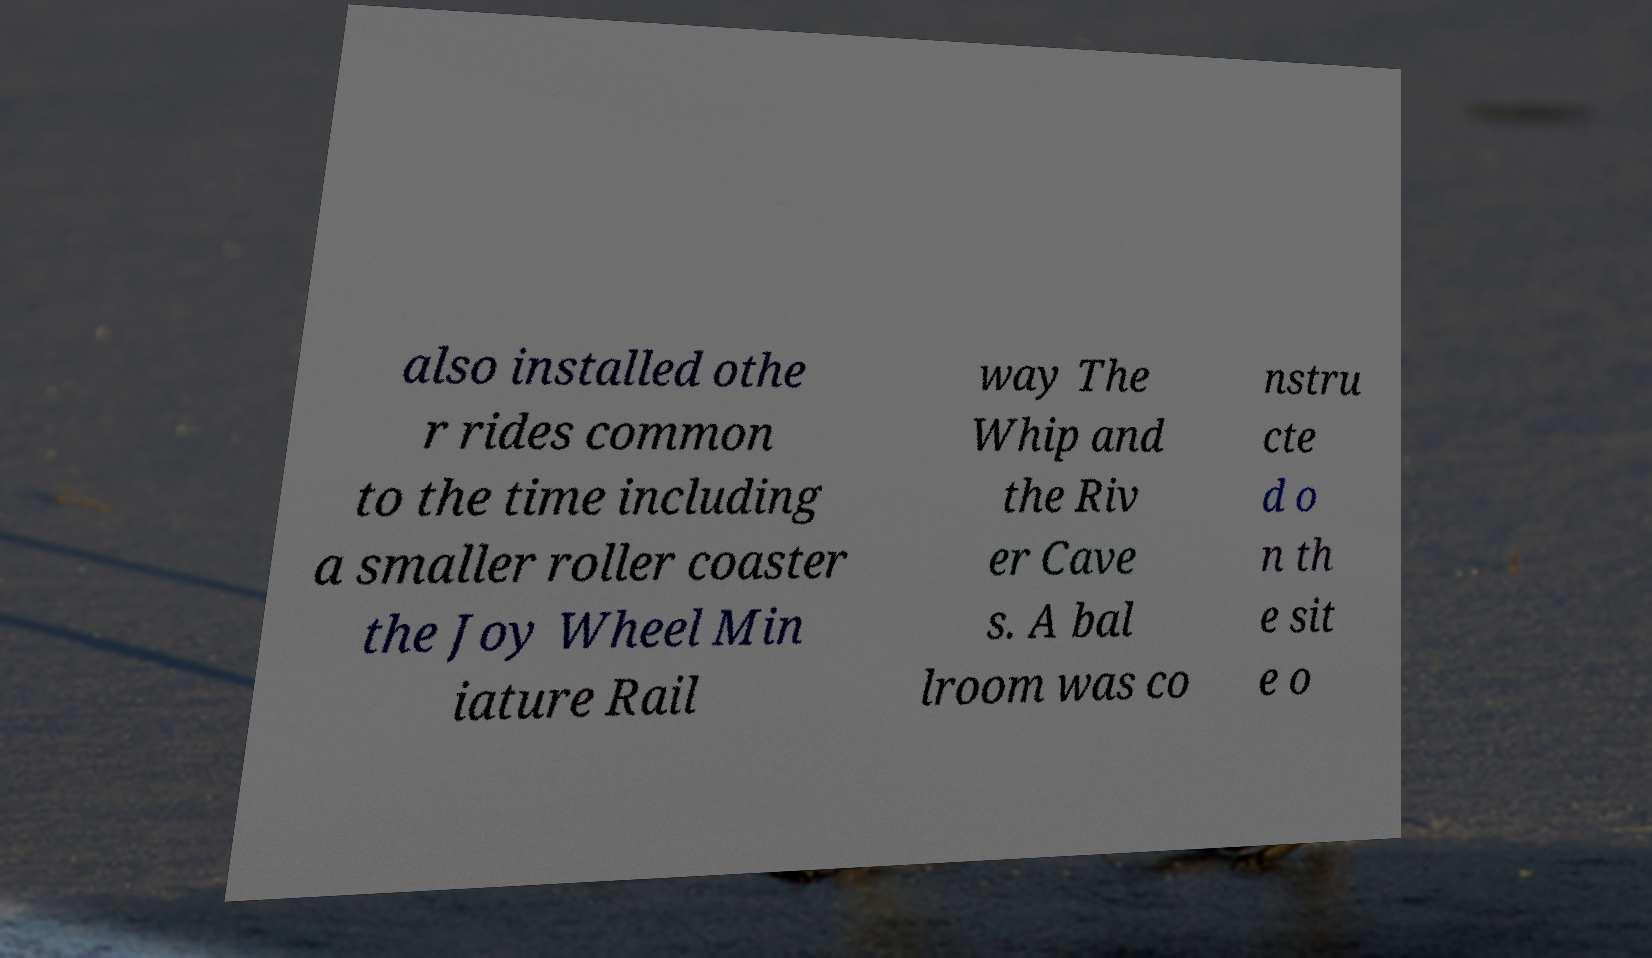Can you accurately transcribe the text from the provided image for me? also installed othe r rides common to the time including a smaller roller coaster the Joy Wheel Min iature Rail way The Whip and the Riv er Cave s. A bal lroom was co nstru cte d o n th e sit e o 